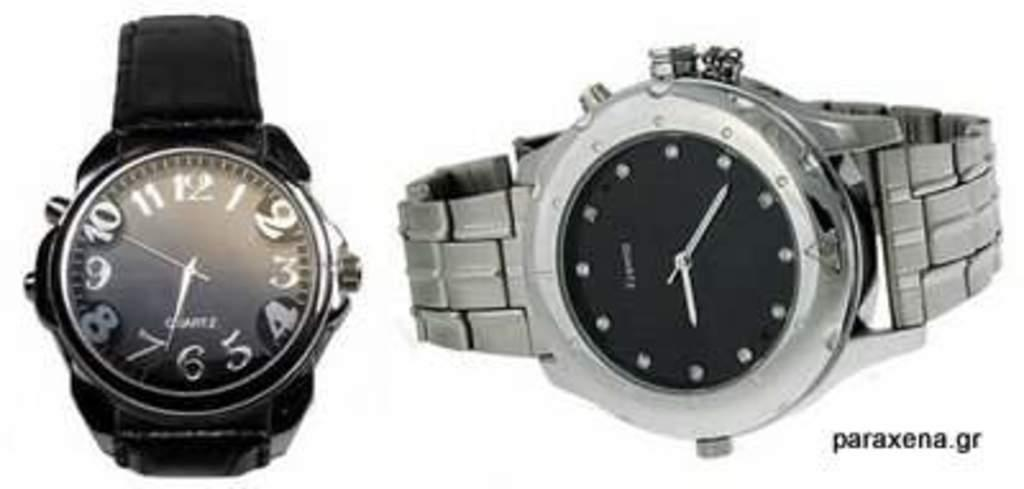Provide a one-sentence caption for the provided image. A black wristwatch and a metal wrist watch available at paraxena.gr. 